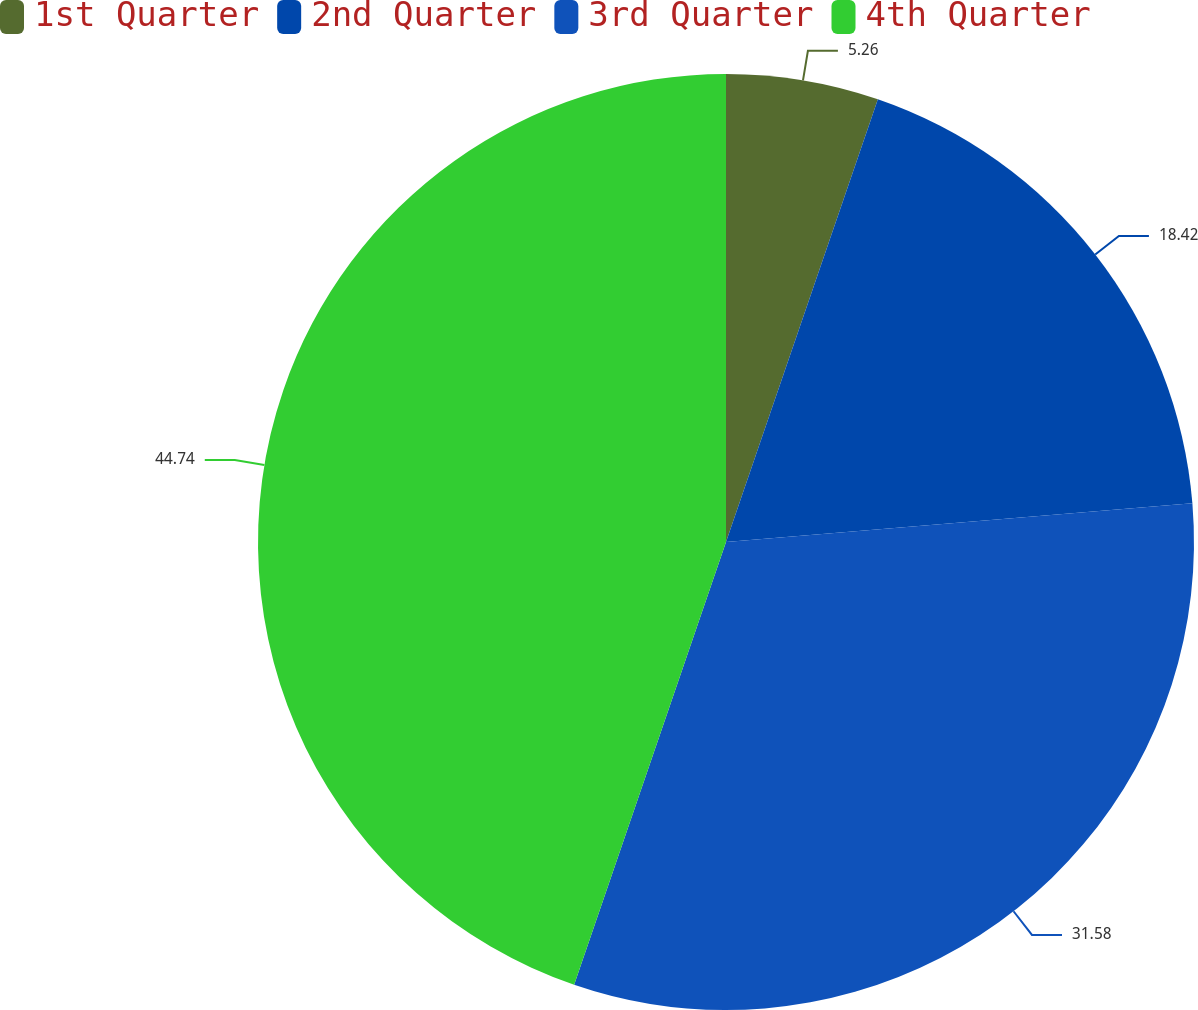Convert chart to OTSL. <chart><loc_0><loc_0><loc_500><loc_500><pie_chart><fcel>1st Quarter<fcel>2nd Quarter<fcel>3rd Quarter<fcel>4th Quarter<nl><fcel>5.26%<fcel>18.42%<fcel>31.58%<fcel>44.74%<nl></chart> 